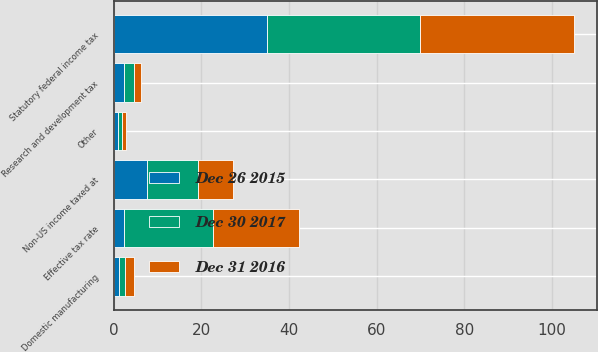<chart> <loc_0><loc_0><loc_500><loc_500><stacked_bar_chart><ecel><fcel>Statutory federal income tax<fcel>Non-US income taxed at<fcel>Research and development tax<fcel>Domestic manufacturing<fcel>Other<fcel>Effective tax rate<nl><fcel>Dec 26 2015<fcel>35<fcel>7.6<fcel>2.3<fcel>1.3<fcel>1.1<fcel>2.3<nl><fcel>Dec 30 2017<fcel>35<fcel>11.7<fcel>2.3<fcel>1.4<fcel>0.8<fcel>20.3<nl><fcel>Dec 31 2016<fcel>35<fcel>7.9<fcel>1.7<fcel>2<fcel>0.9<fcel>19.6<nl></chart> 